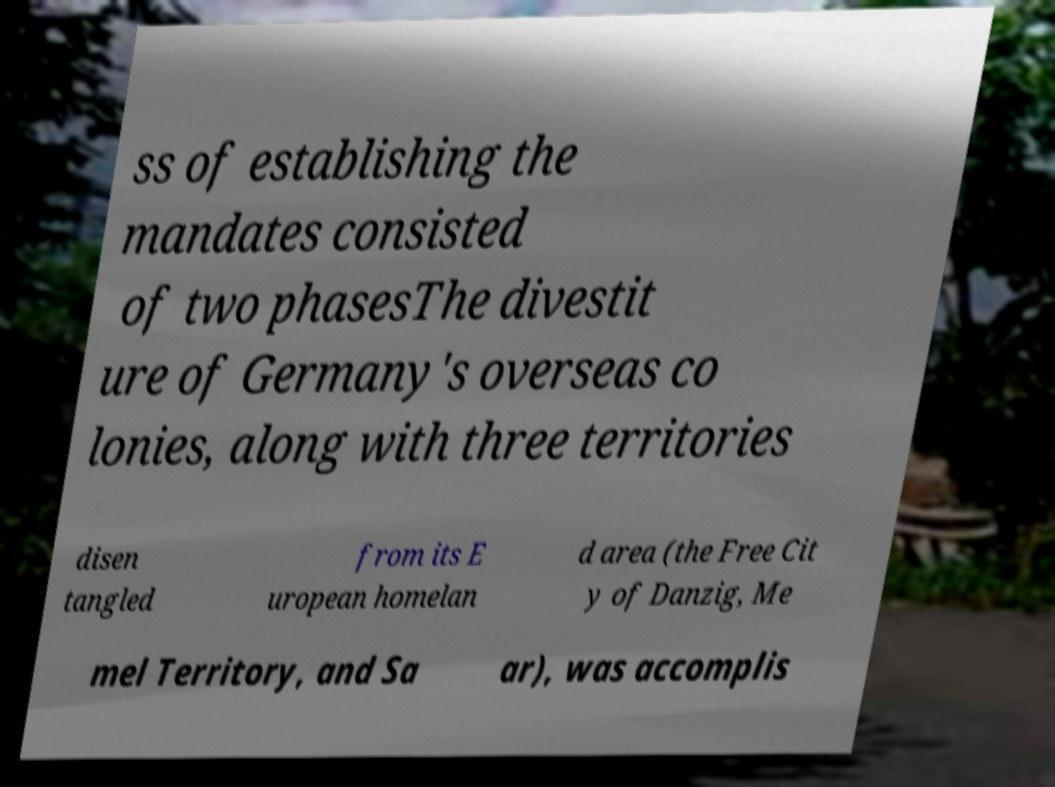There's text embedded in this image that I need extracted. Can you transcribe it verbatim? ss of establishing the mandates consisted of two phasesThe divestit ure of Germany's overseas co lonies, along with three territories disen tangled from its E uropean homelan d area (the Free Cit y of Danzig, Me mel Territory, and Sa ar), was accomplis 